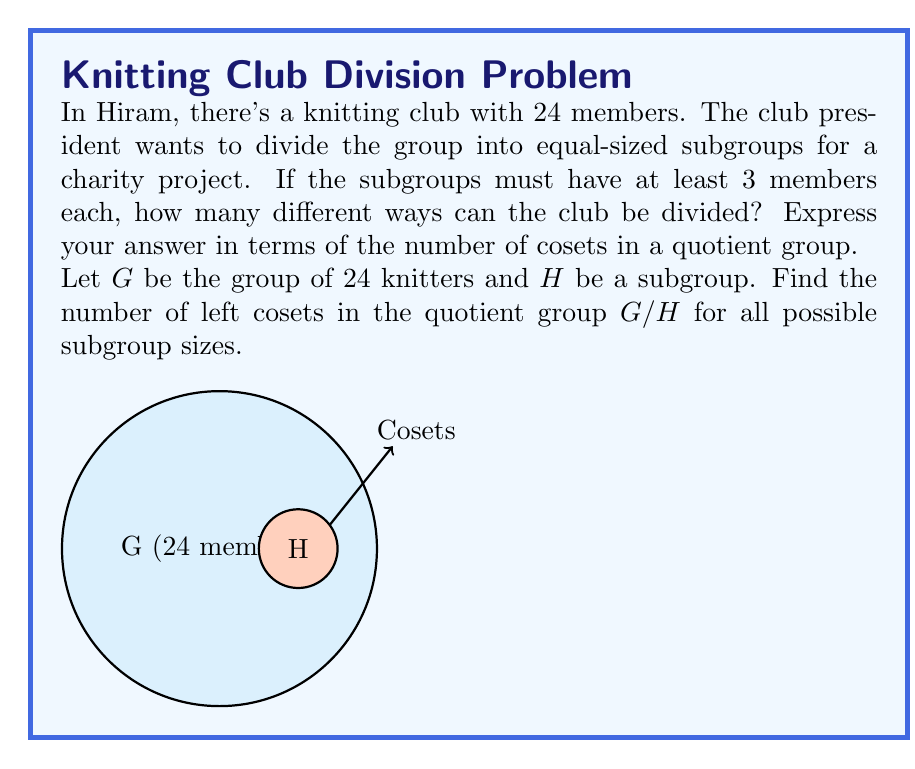Could you help me with this problem? Let's approach this step-by-step:

1) The possible subgroup sizes (order of H) are the divisors of 24:
   $|H| \in \{1, 2, 3, 4, 6, 8, 12, 24\}$

2) The number of cosets in $G/H$ is given by the index of $H$ in $G$, which is:

   $[G:H] = \frac{|G|}{|H|} = \frac{24}{|H|}$

3) Let's calculate the number of cosets for each possible $|H|$:

   For $|H| = 1$:  $\frac{24}{1} = 24$ cosets
   For $|H| = 2$:  $\frac{24}{2} = 12$ cosets
   For $|H| = 3$:  $\frac{24}{3} = 8$ cosets
   For $|H| = 4$:  $\frac{24}{4} = 6$ cosets
   For $|H| = 6$:  $\frac{24}{6} = 4$ cosets
   For $|H| = 8$:  $\frac{24}{8} = 3$ cosets
   For $|H| = 12$: $\frac{24}{12} = 2$ cosets
   For $|H| = 24$: $\frac{24}{24} = 1$ coset

4) The question asks for subgroups with at least 3 members, so we exclude the cases where $|H| = 1$ and $|H| = 2$.

5) Therefore, the possible numbers of ways to divide the club (i.e., the number of cosets) are:
   $\{8, 6, 4, 3, 2, 1\}$

This represents all the ways the knitting club can be divided into equal-sized subgroups of at least 3 members each.
Answer: $\{8, 6, 4, 3, 2, 1\}$ 